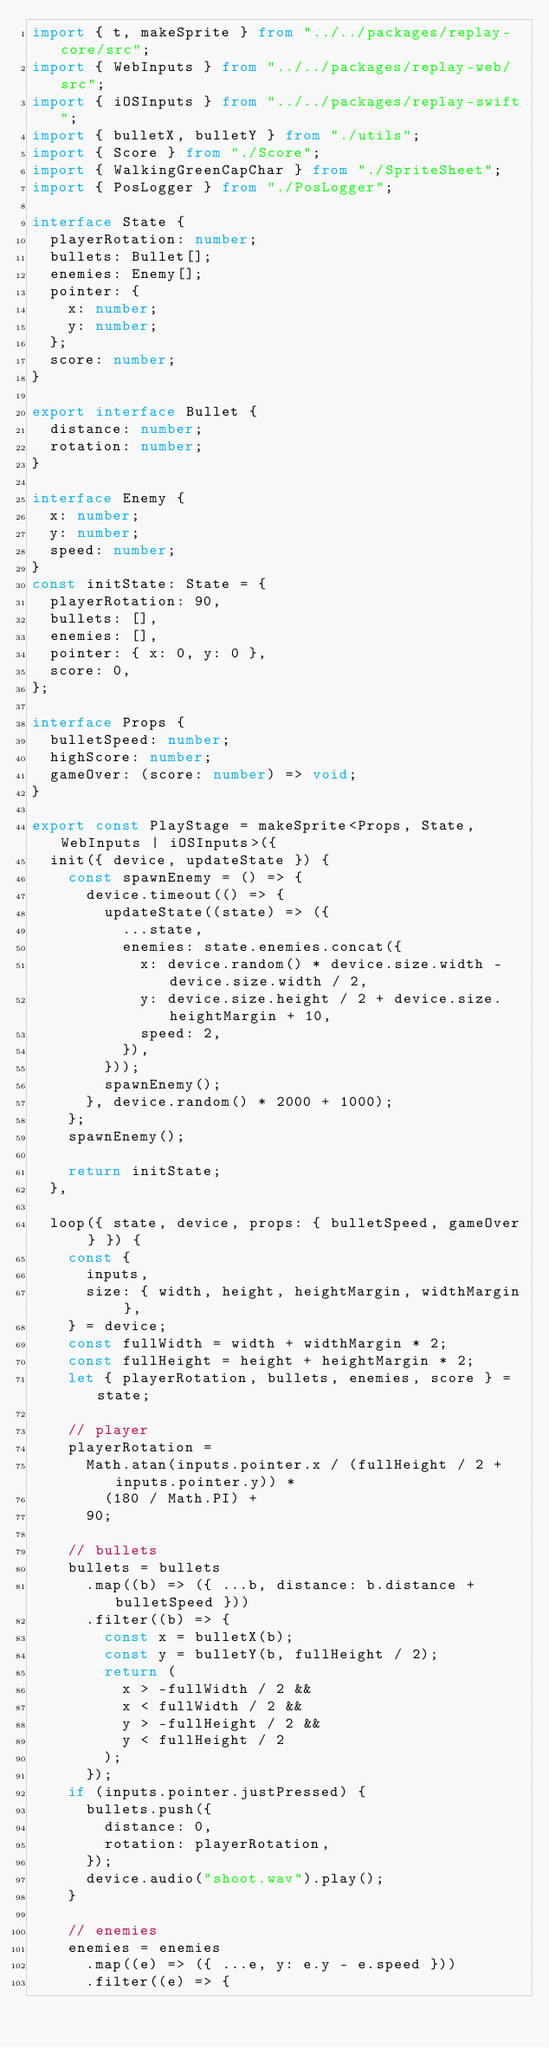<code> <loc_0><loc_0><loc_500><loc_500><_TypeScript_>import { t, makeSprite } from "../../packages/replay-core/src";
import { WebInputs } from "../../packages/replay-web/src";
import { iOSInputs } from "../../packages/replay-swift";
import { bulletX, bulletY } from "./utils";
import { Score } from "./Score";
import { WalkingGreenCapChar } from "./SpriteSheet";
import { PosLogger } from "./PosLogger";

interface State {
  playerRotation: number;
  bullets: Bullet[];
  enemies: Enemy[];
  pointer: {
    x: number;
    y: number;
  };
  score: number;
}

export interface Bullet {
  distance: number;
  rotation: number;
}

interface Enemy {
  x: number;
  y: number;
  speed: number;
}
const initState: State = {
  playerRotation: 90,
  bullets: [],
  enemies: [],
  pointer: { x: 0, y: 0 },
  score: 0,
};

interface Props {
  bulletSpeed: number;
  highScore: number;
  gameOver: (score: number) => void;
}

export const PlayStage = makeSprite<Props, State, WebInputs | iOSInputs>({
  init({ device, updateState }) {
    const spawnEnemy = () => {
      device.timeout(() => {
        updateState((state) => ({
          ...state,
          enemies: state.enemies.concat({
            x: device.random() * device.size.width - device.size.width / 2,
            y: device.size.height / 2 + device.size.heightMargin + 10,
            speed: 2,
          }),
        }));
        spawnEnemy();
      }, device.random() * 2000 + 1000);
    };
    spawnEnemy();

    return initState;
  },

  loop({ state, device, props: { bulletSpeed, gameOver } }) {
    const {
      inputs,
      size: { width, height, heightMargin, widthMargin },
    } = device;
    const fullWidth = width + widthMargin * 2;
    const fullHeight = height + heightMargin * 2;
    let { playerRotation, bullets, enemies, score } = state;

    // player
    playerRotation =
      Math.atan(inputs.pointer.x / (fullHeight / 2 + inputs.pointer.y)) *
        (180 / Math.PI) +
      90;

    // bullets
    bullets = bullets
      .map((b) => ({ ...b, distance: b.distance + bulletSpeed }))
      .filter((b) => {
        const x = bulletX(b);
        const y = bulletY(b, fullHeight / 2);
        return (
          x > -fullWidth / 2 &&
          x < fullWidth / 2 &&
          y > -fullHeight / 2 &&
          y < fullHeight / 2
        );
      });
    if (inputs.pointer.justPressed) {
      bullets.push({
        distance: 0,
        rotation: playerRotation,
      });
      device.audio("shoot.wav").play();
    }

    // enemies
    enemies = enemies
      .map((e) => ({ ...e, y: e.y - e.speed }))
      .filter((e) => {</code> 